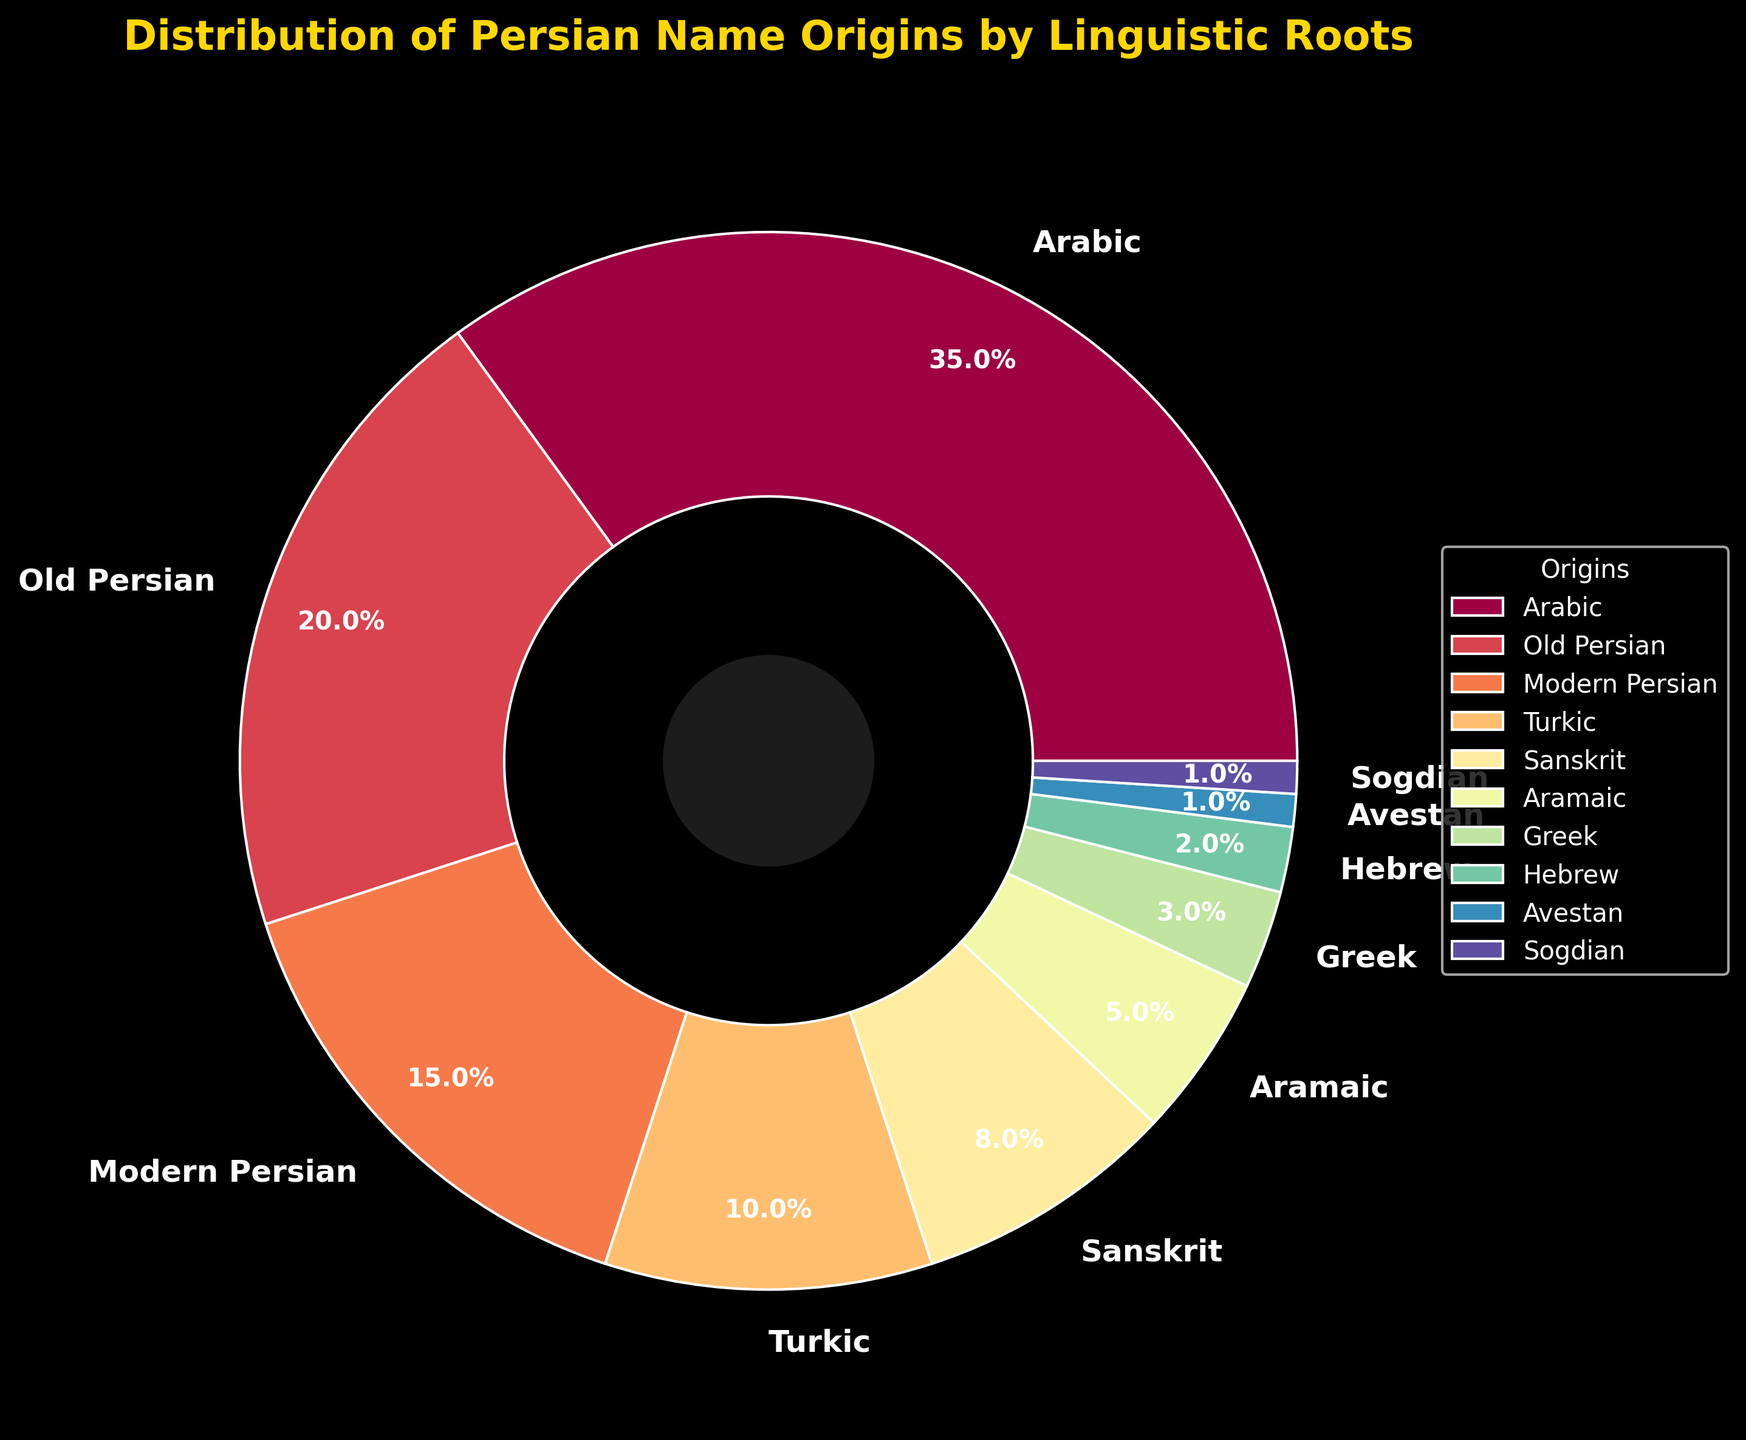What's the most common linguistic root for Persian names according to the chart? The largest wedge in the pie chart represents 'Arabic,' indicating it has the highest percentage.
Answer: Arabic What is the combined percentage of names from Old Persian and Modern Persian origins? Old Persian accounts for 20% and Modern Persian for 15%. Adding these percentages together gives 20% + 15% = 35%.
Answer: 35% Which linguistic roots have a percentage less than 5%? The wedges labeled 'Greek', 'Hebrew', 'Avestan', and 'Sogdian' all have percentages less than 5%, specifically 3%, 2%, 1%, and 1%, respectively.
Answer: Greek, Hebrew, Avestan, Sogdian How much more common are Arabic-origin names compared to Turkic-origin names in the figure? Arabic-origin names account for 35% while Turkic-origin names account for 10%. The difference is 35% - 10% = 25%.
Answer: 25% What percentage of names have origins listed as either Sanskrit or Aramaic? Sanskrit-origin names are 8% and Aramaic-origin names are 5%. Adding these together gives 8% + 5% = 13%.
Answer: 13% Which linguistic root has the smallest percentage and how does it compare visually to the other roots? Avestan and Sogdian both have the smallest percentage at 1%. Visually, their wedges are much smaller compared to the other roots.
Answer: Avestan and Sogdian; much smaller Is the percentage of Turkic-origin names greater than Sanskrit-origin names according to the chart? Turkic origins account for 10%, while Sanskrit origins account for 8%. Therefore, Turkic-origin names have a higher percentage.
Answer: Yes Which of the origins constitute more than half of the total linguistic roots combined? Arabic alone makes up 35%, and combining it with Old Persian (20%) reaches 55%. Since 55% is more than half, Arabic and Old Persian together fit this criterion.
Answer: Arabic and Old Persian Considering the colors in the chart, which linguistic root has the lightest color and what is its percentage? The pie chart shows 'Old Persian' with a markedly lighter color compared to others. It accounts for 20% of the names.
Answer: Old Persian, 20% If you were to merge the percentages of the three least common origins, what would their total be? The least common origins are Avestan, Sogdian, and Hebrew, each at 1%, 1%, and 2% respectively. Their total is 1% + 1% + 2% = 4%.
Answer: 4% 